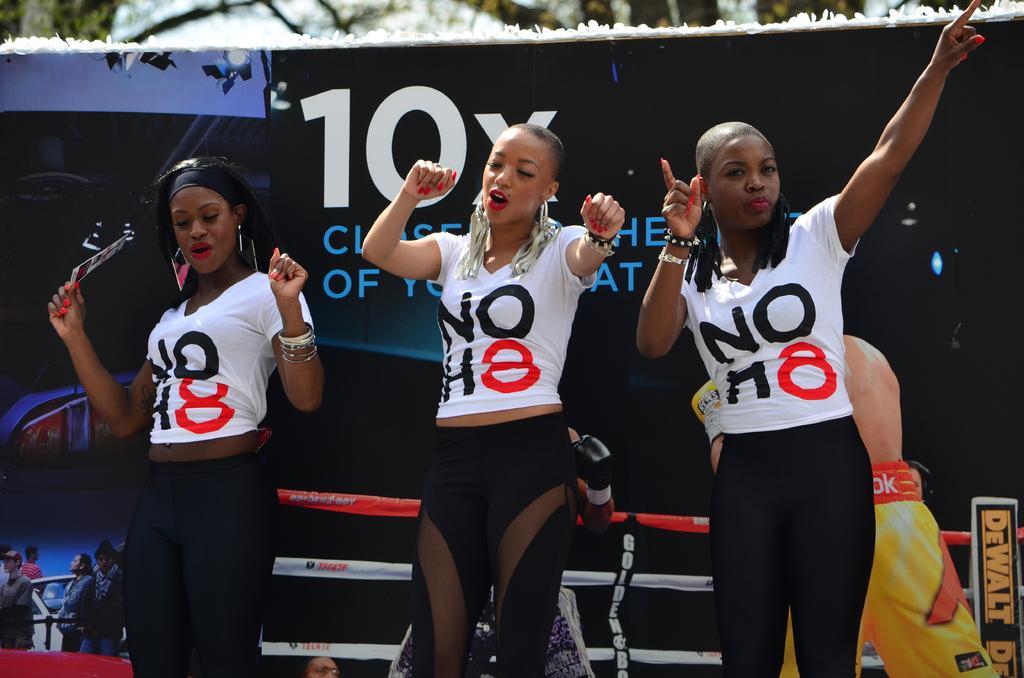Could you give a brief overview of what you see in this image? In the foreground I can see three persons are performing a dance on the floor. In the background I can see a poster, board, snow, trees and the sky. This image is taken may be during a day. 